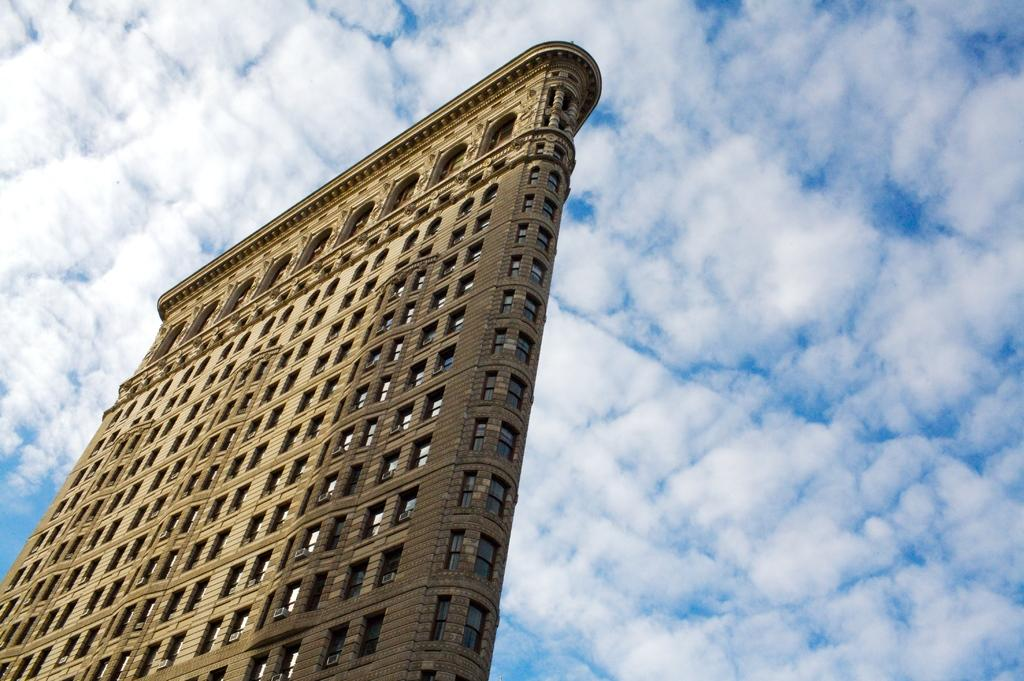What is the main subject in the center of the image? There is a building in the center of the image. What can be seen in the background of the image? The sky is visible in the background of the image. How does the building take a breath in the image? Buildings do not breathe, so this question is not applicable to the image. 